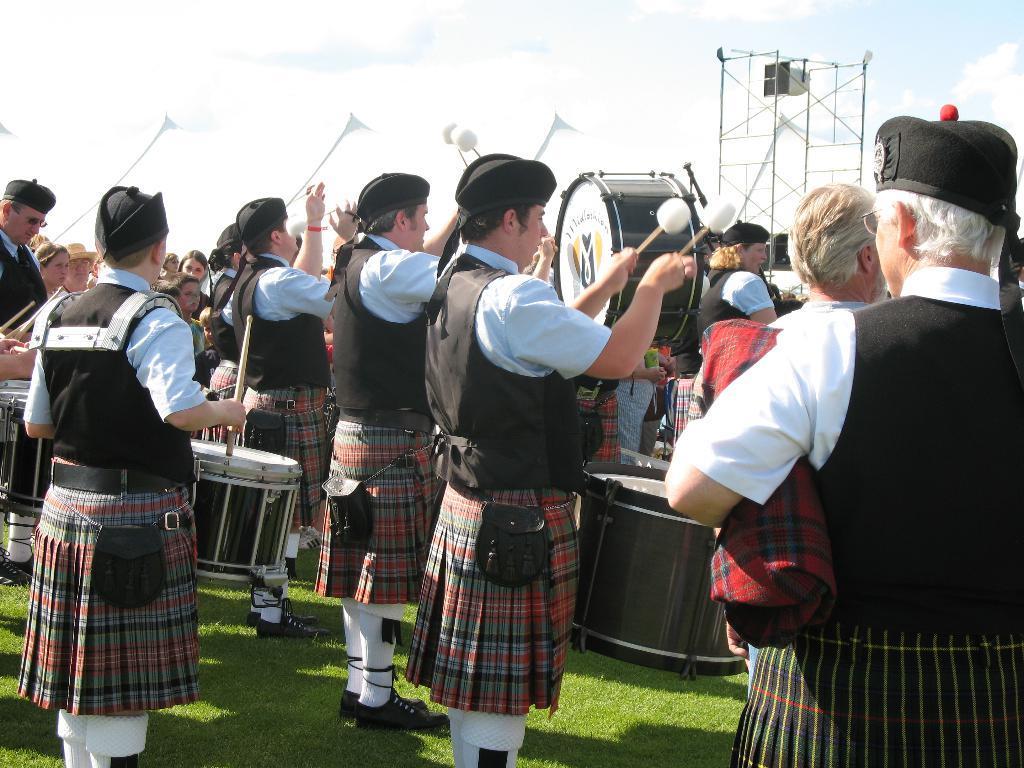Describe this image in one or two sentences. In this image there are group of people who are wearing the jackets and skirts are beating the drums. In the background there is a stand. At the top there is the sky. At the bottom there is grass. There is a person on the right side who is holding the cloth. 